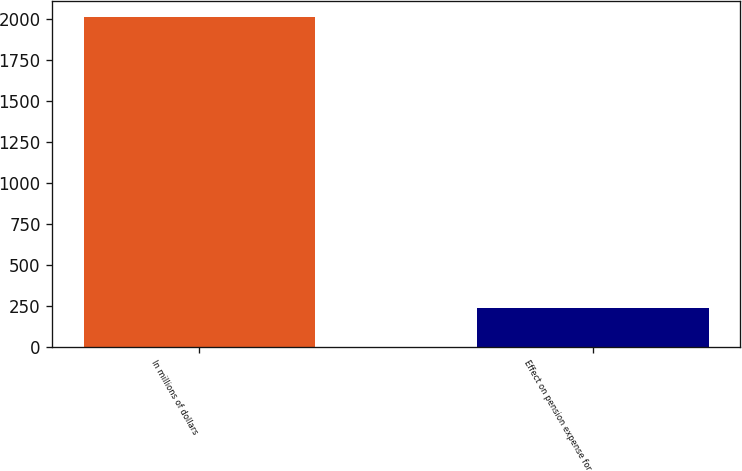Convert chart to OTSL. <chart><loc_0><loc_0><loc_500><loc_500><bar_chart><fcel>In millions of dollars<fcel>Effect on pension expense for<nl><fcel>2008<fcel>233.2<nl></chart> 